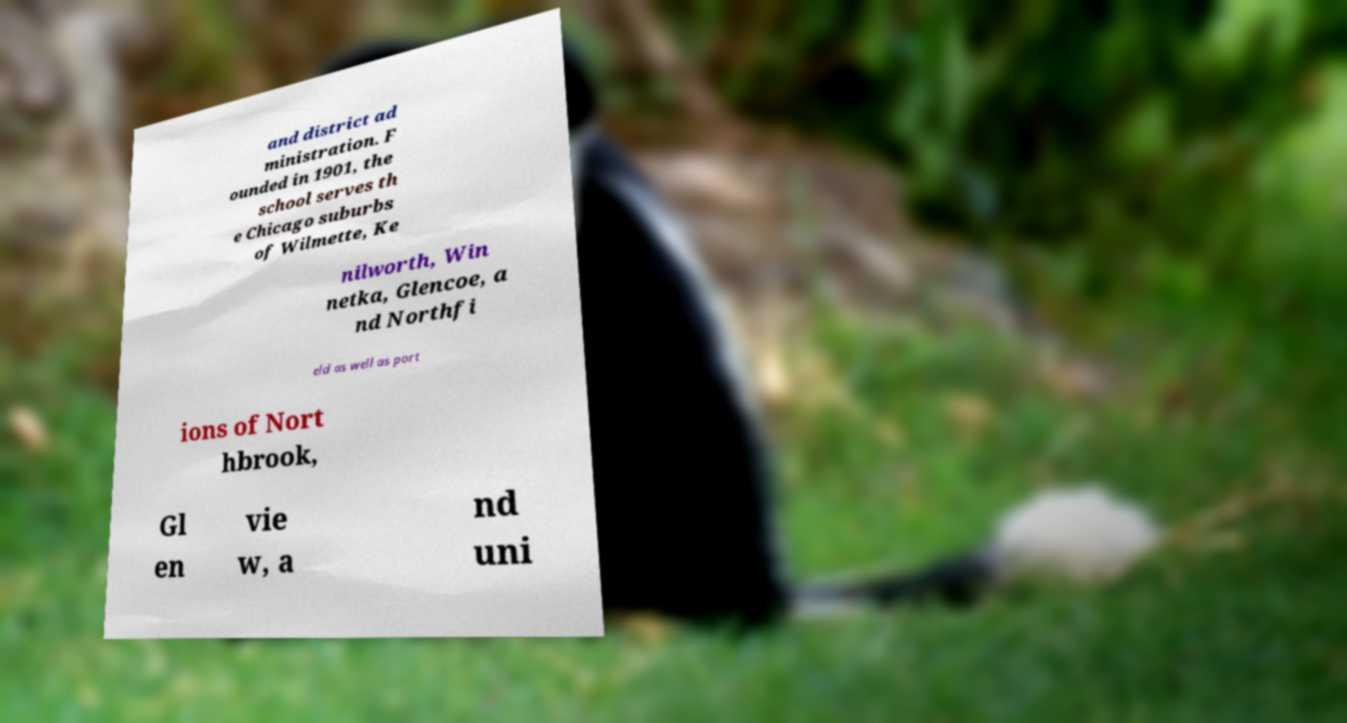For documentation purposes, I need the text within this image transcribed. Could you provide that? and district ad ministration. F ounded in 1901, the school serves th e Chicago suburbs of Wilmette, Ke nilworth, Win netka, Glencoe, a nd Northfi eld as well as port ions of Nort hbrook, Gl en vie w, a nd uni 